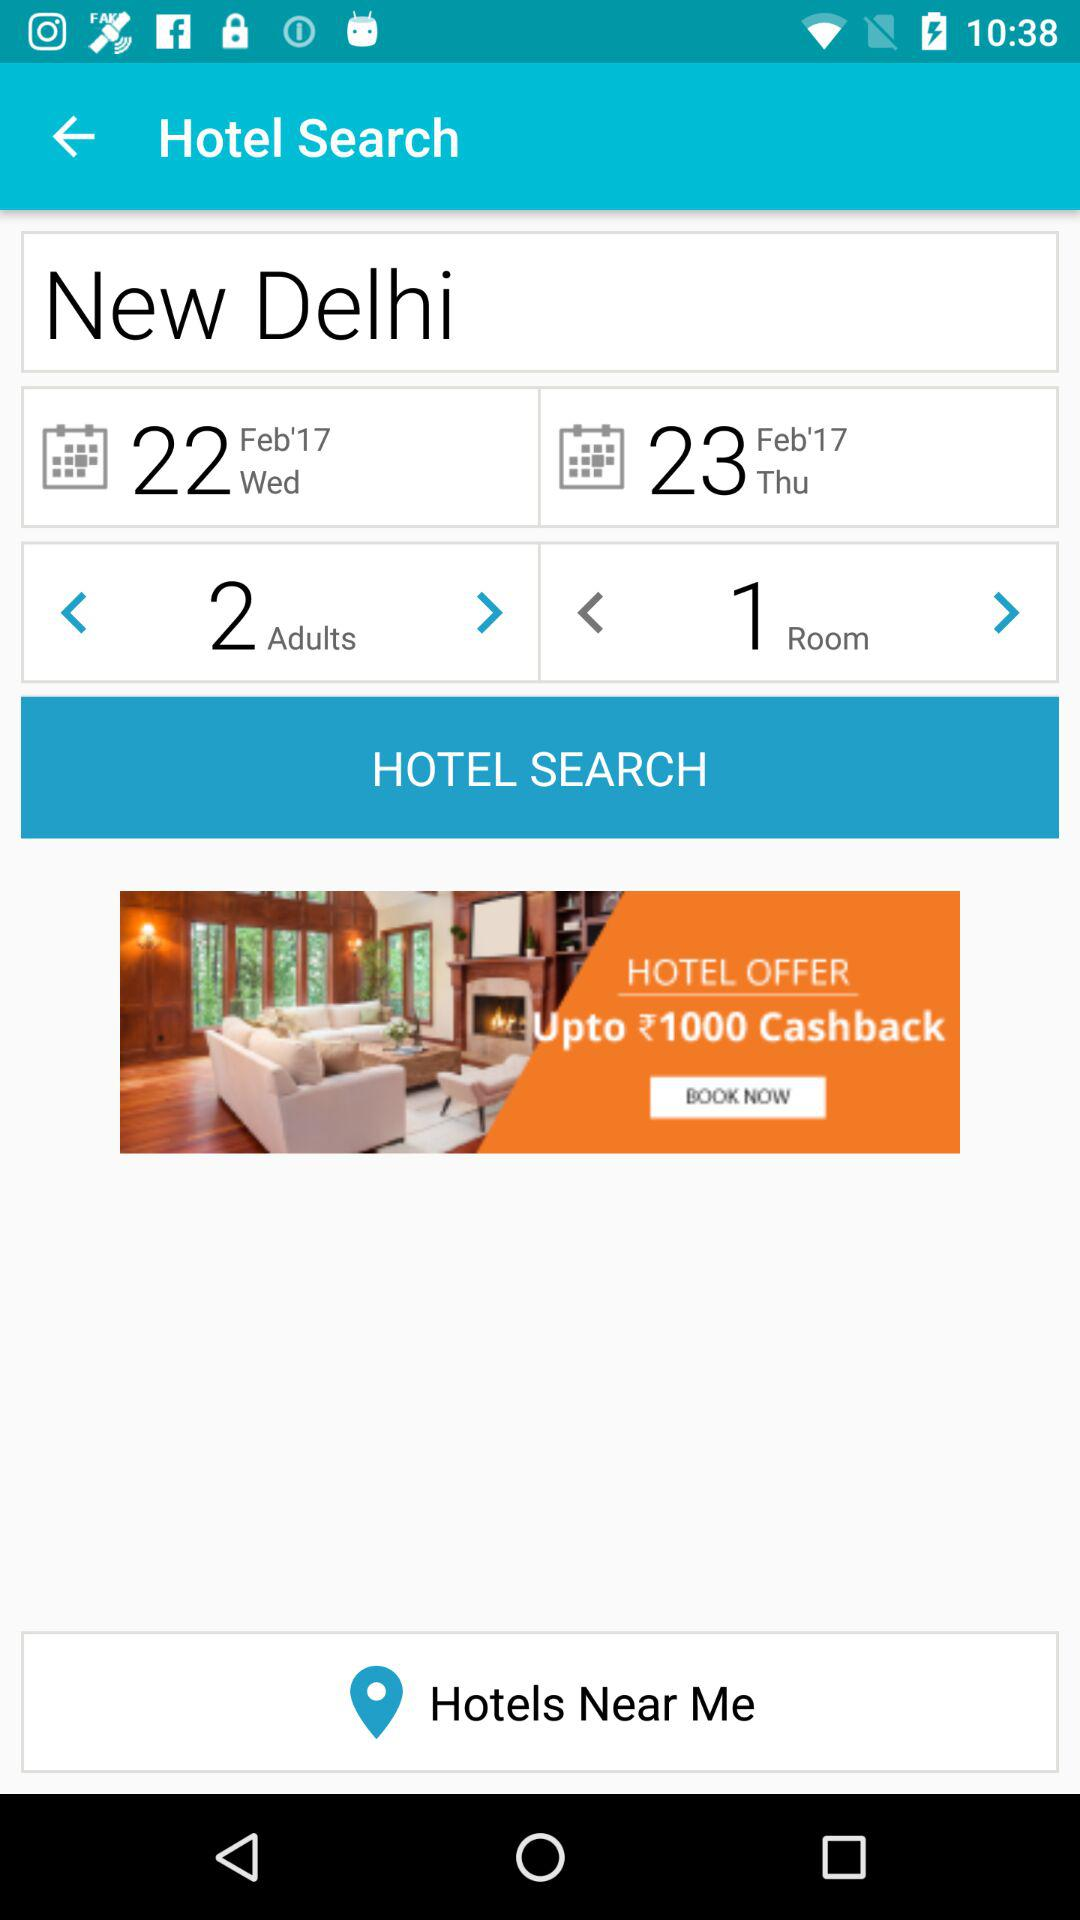What are the selected dates? The selected dates are Wednesday, February 22, 2017 and Thursday, February 22, 2017. 